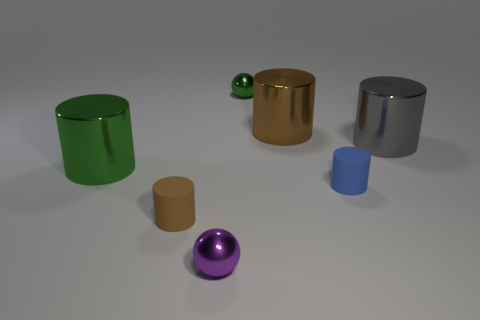Subtract all purple cubes. How many brown cylinders are left? 2 Add 2 gray shiny objects. How many objects exist? 9 Subtract all green metallic cylinders. How many cylinders are left? 4 Subtract all brown cylinders. How many cylinders are left? 3 Subtract all cylinders. How many objects are left? 2 Subtract all blue cylinders. Subtract all yellow blocks. How many cylinders are left? 4 Subtract all tiny metal spheres. Subtract all big red matte spheres. How many objects are left? 5 Add 1 tiny purple objects. How many tiny purple objects are left? 2 Add 6 small green matte things. How many small green matte things exist? 6 Subtract 1 brown cylinders. How many objects are left? 6 